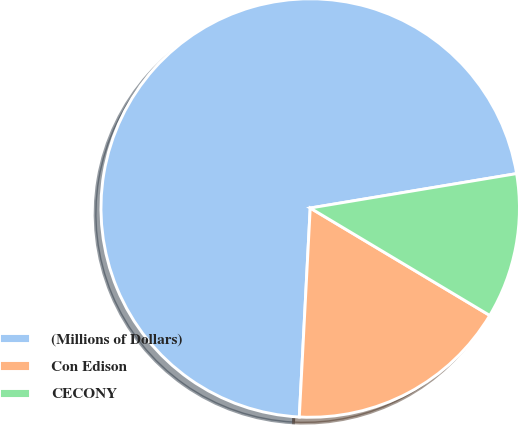<chart> <loc_0><loc_0><loc_500><loc_500><pie_chart><fcel>(Millions of Dollars)<fcel>Con Edison<fcel>CECONY<nl><fcel>71.54%<fcel>17.25%<fcel>11.21%<nl></chart> 